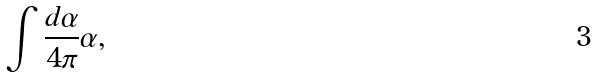<formula> <loc_0><loc_0><loc_500><loc_500>\int \frac { d \alpha } { 4 \pi } \alpha ,</formula> 